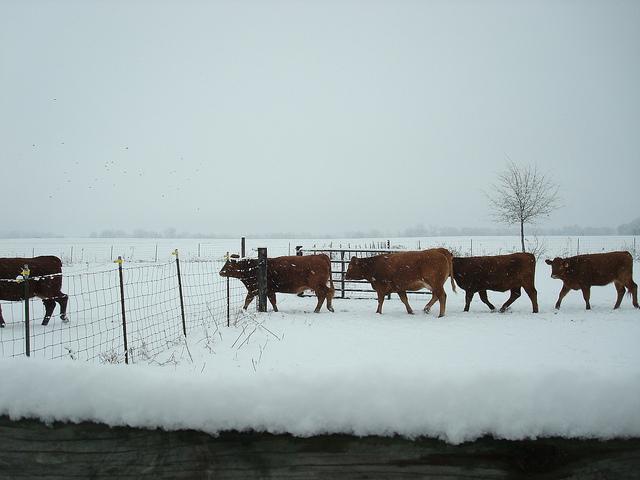How many male cows are there in the photograph?
Concise answer only. 5. How many cows are there?
Concise answer only. 5. Are the cows walking in the snow?
Short answer required. Yes. 